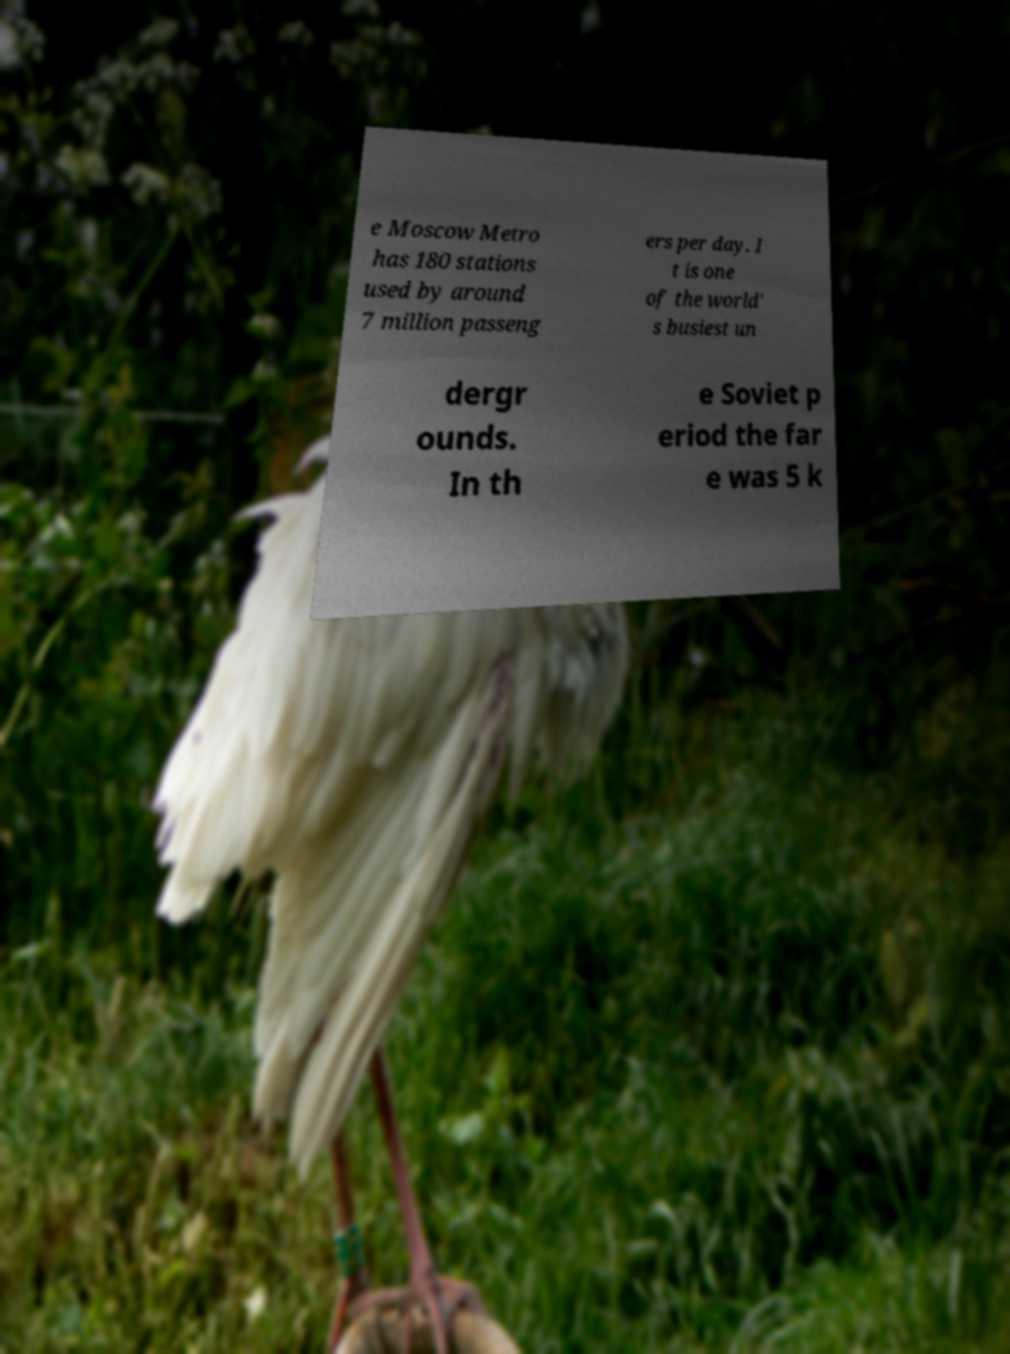Can you accurately transcribe the text from the provided image for me? e Moscow Metro has 180 stations used by around 7 million passeng ers per day. I t is one of the world' s busiest un dergr ounds. In th e Soviet p eriod the far e was 5 k 